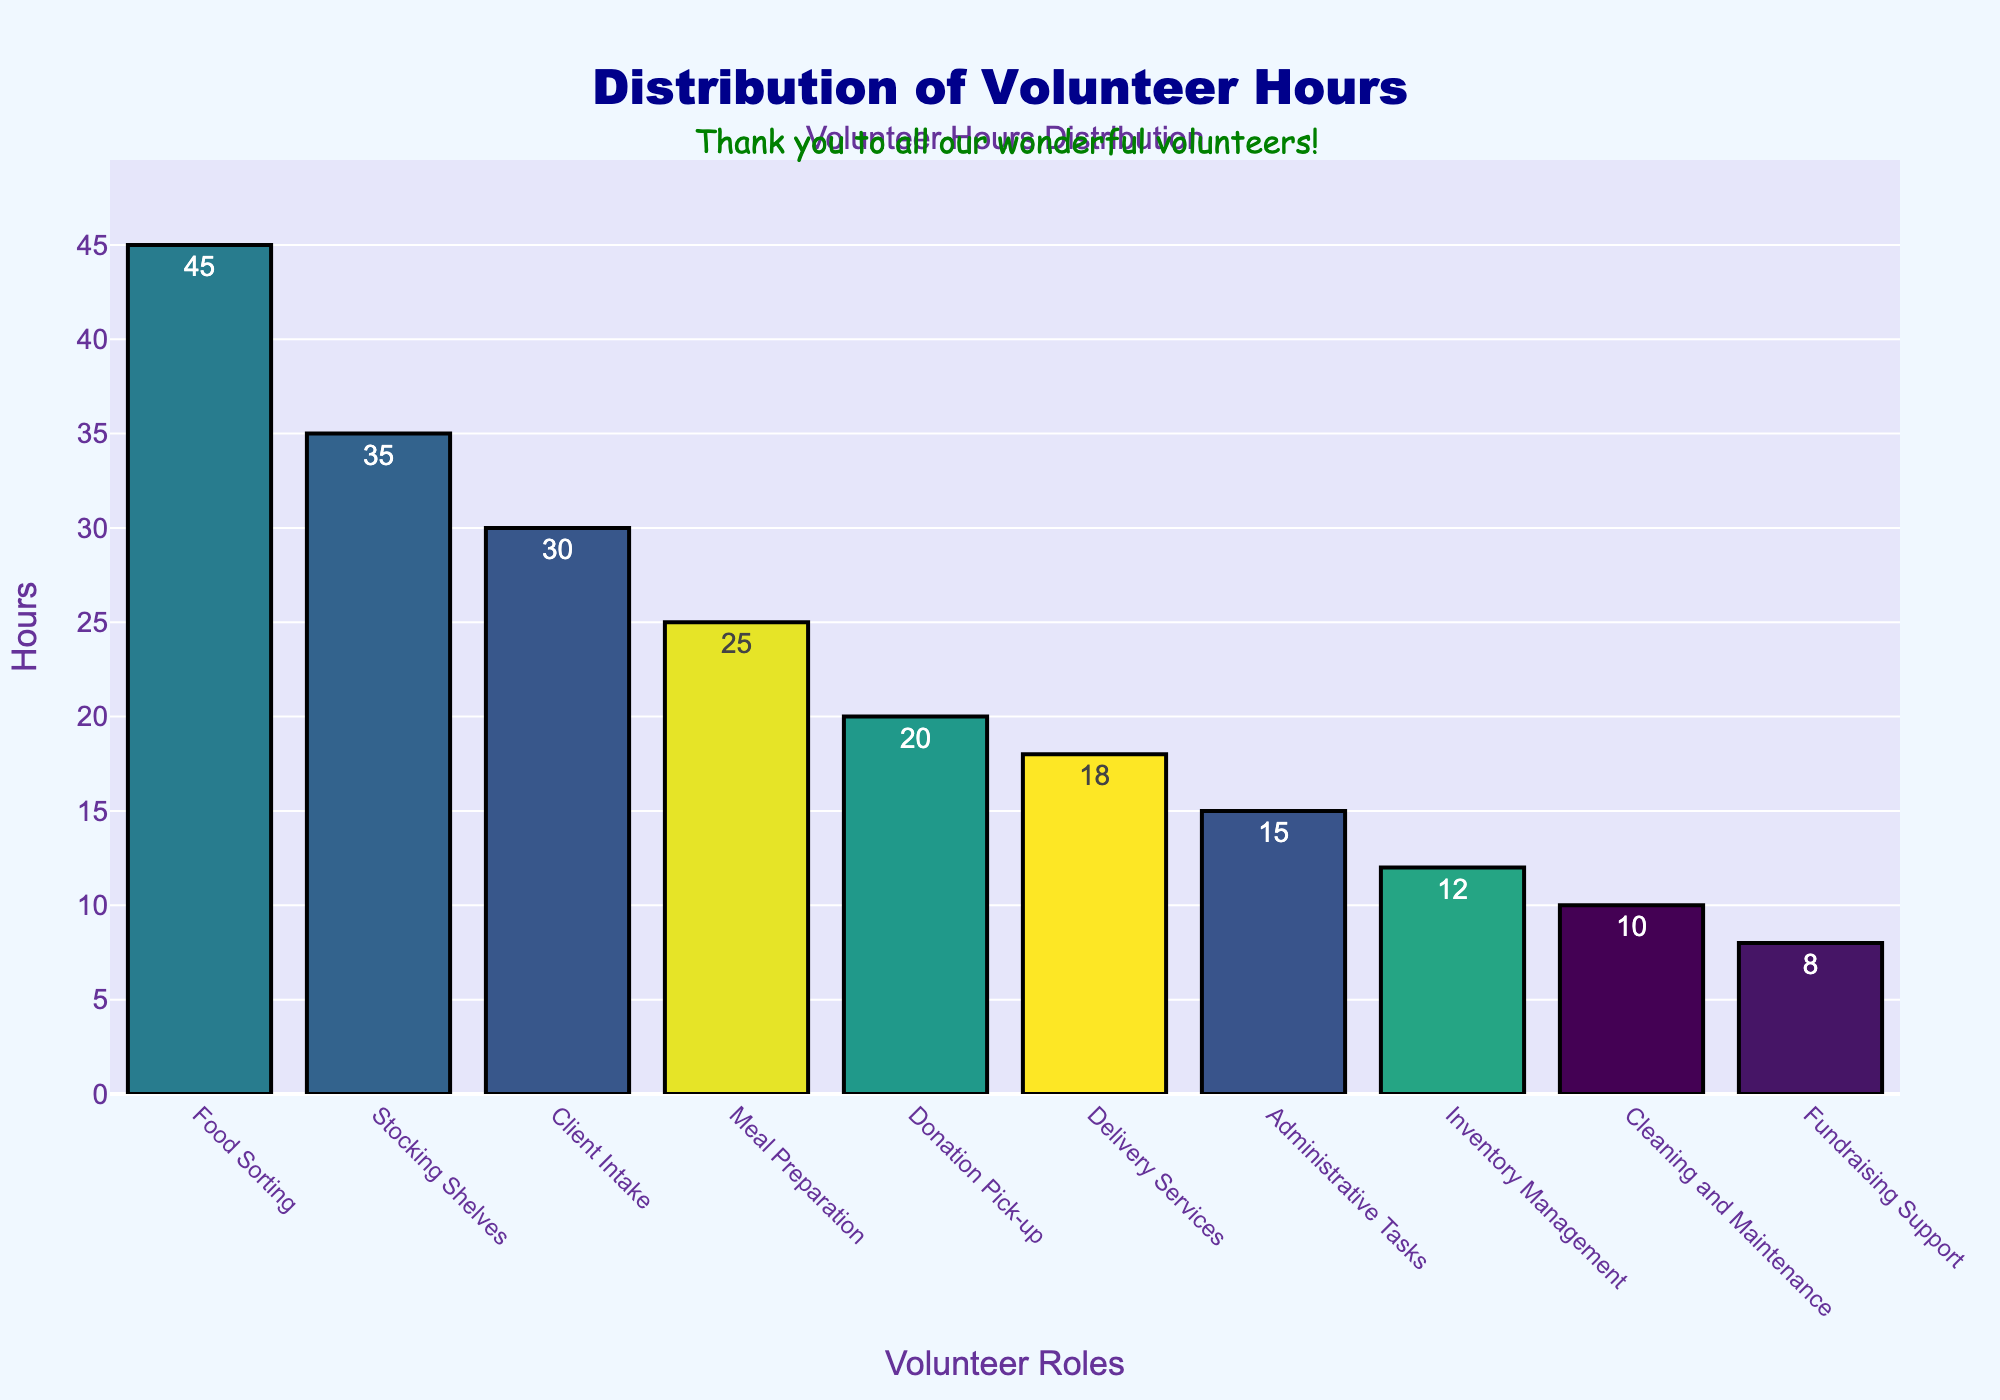Which role has the highest number of volunteer hours? The bar for "Food Sorting" is the tallest, indicating it has the highest number of volunteer hours.
Answer: Food Sorting Which role has the lowest number of volunteer hours? The bar for "Fundraising Support" is the shortest, indicating it has the lowest number of volunteer hours.
Answer: Fundraising Support What is the combined number of hours for 'Client Intake' and 'Meal Preparation'? Summing up the hours for both roles: 'Client Intake' (30 hours) + 'Meal Preparation' (25 hours) = 55 hours.
Answer: 55 Are there more volunteer hours allocated to 'Cleaning and Maintenance' or 'Delivery Services'? Comparing the heights of the bars for both roles, 'Delivery Services' (18 hours) has more hours than 'Cleaning and Maintenance' (10 hours).
Answer: Delivery Services What is the difference between the highest and lowest volunteer hours? Subtracting the lowest hours from the highest: 'Food Sorting' (45 hours) - 'Fundraising Support' (8 hours) = 37 hours.
Answer: 37 Which role has more volunteer hours, 'Stocking Shelves' or 'Inventory Management'? The bar for 'Stocking Shelves' (35 hours) is taller than the bar for 'Inventory Management' (12 hours).
Answer: Stocking Shelves What is the average number of volunteer hours across all roles? Sum all hours: 45 + 30 + 35 + 20 + 15 + 25 + 10 + 18 + 12 + 8 = 218. Divide by the number of roles (10): 218 / 10 = 21.8 hours.
Answer: 21.8 Which roles have volunteer hours above the average? The average is 21.8 hours. Roles with hours above this are 'Food Sorting' (45), 'Client Intake' (30), 'Stocking Shelves' (35), 'Donation Pick-up' (20), and 'Meal Preparation' (25).
Answer: Food Sorting, Client Intake, Stocking Shelves, Meal Preparation How many roles have less than 20 volunteer hours? Counting the roles: 'Donation Pick-up' (20), 'Administrative Tasks' (15), 'Cleaning and Maintenance' (10), 'Delivery Services' (18), 'Inventory Management' (12), and 'Fundraising Support' (8). There are 5 roles.
Answer: 5 